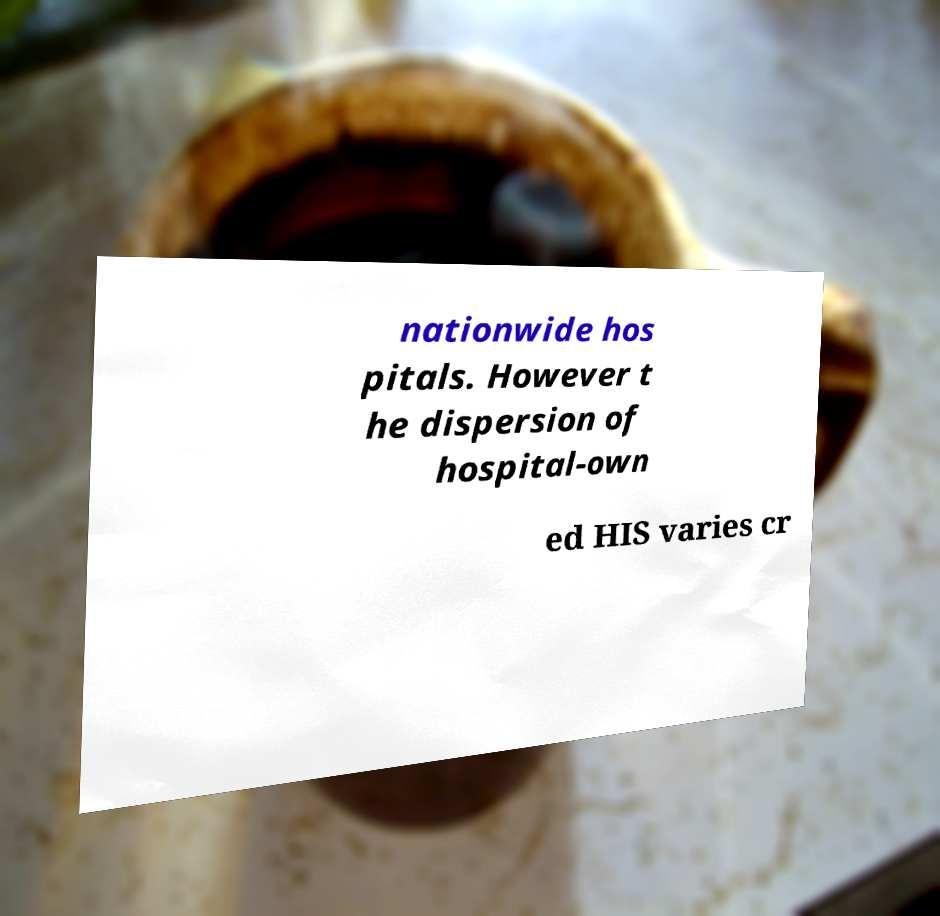Can you read and provide the text displayed in the image?This photo seems to have some interesting text. Can you extract and type it out for me? nationwide hos pitals. However t he dispersion of hospital-own ed HIS varies cr 